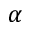<formula> <loc_0><loc_0><loc_500><loc_500>\alpha</formula> 